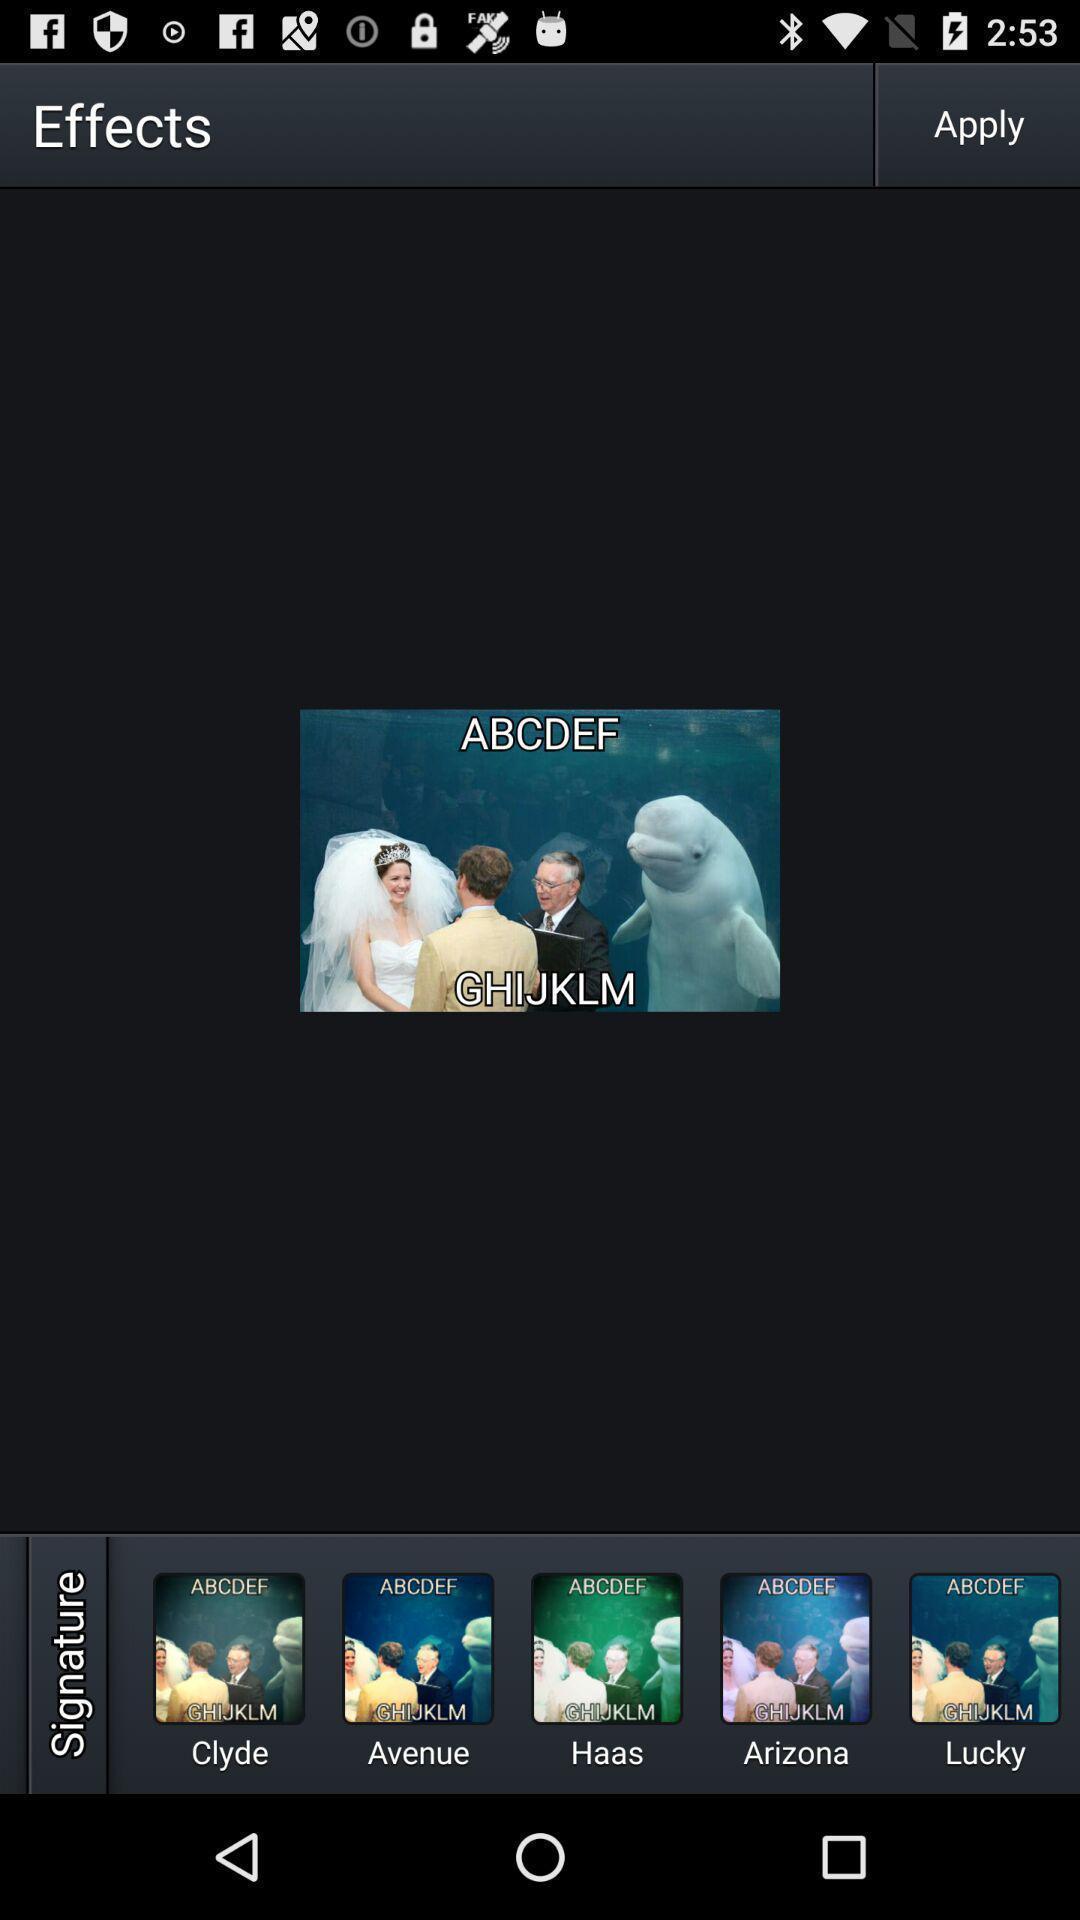What can you discern from this picture? Page showing different picture effects. 